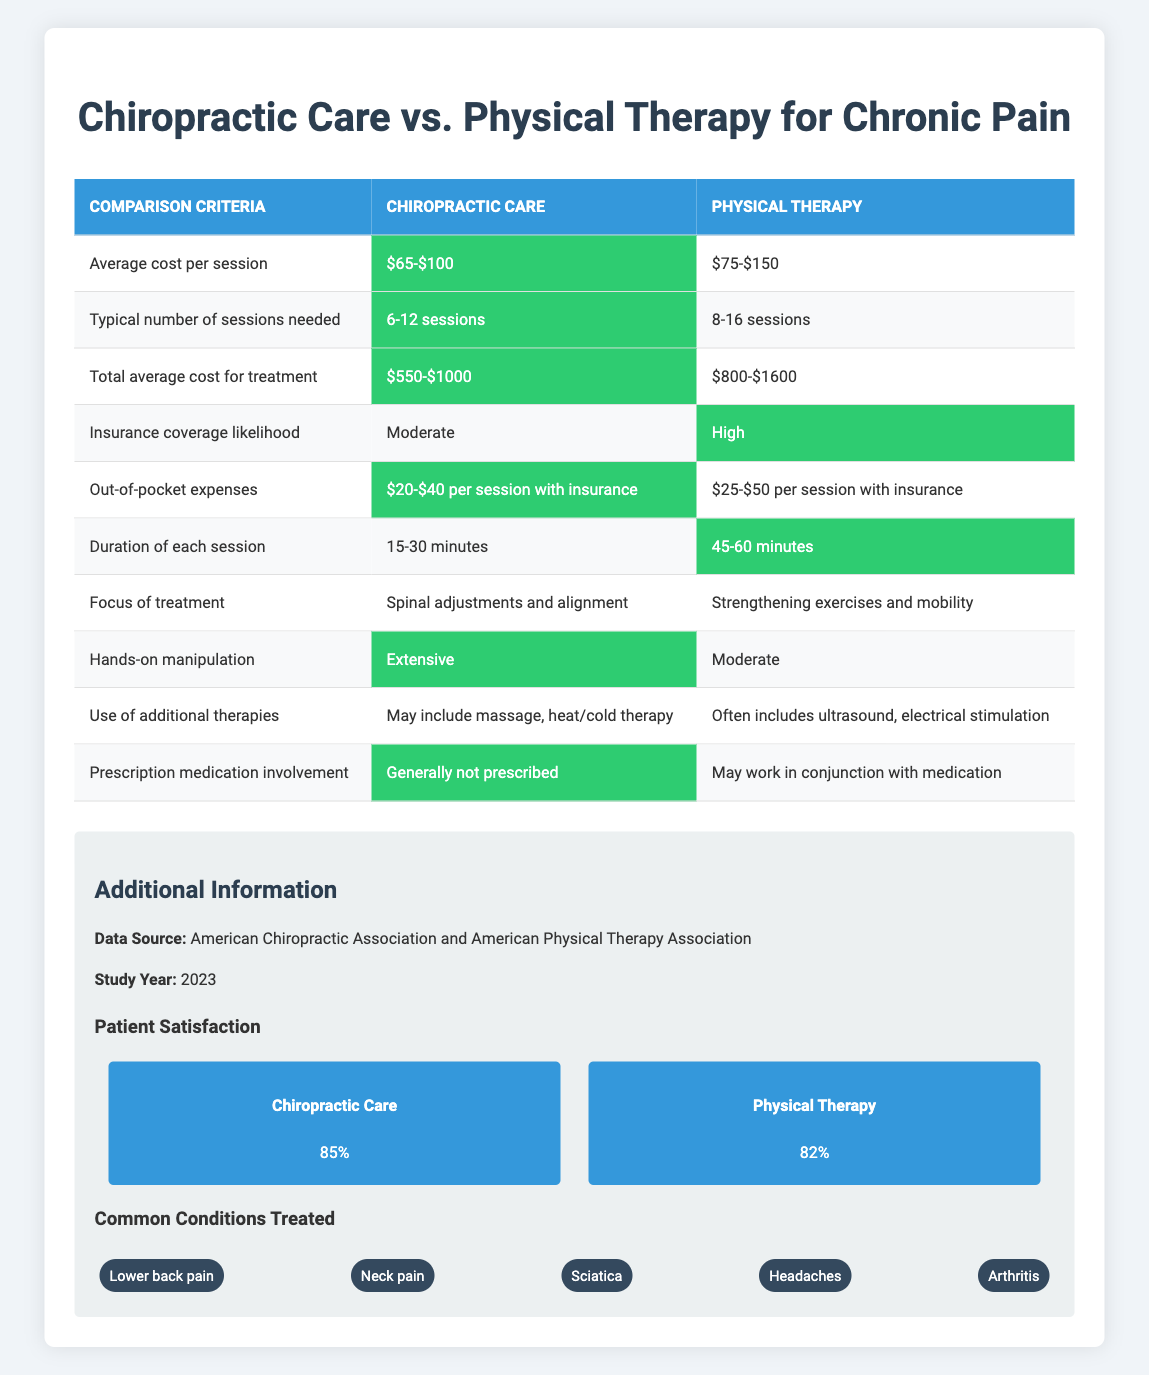What is the average cost per session for chiropractic care? The table states that the average cost per session for chiropractic care ranges from $65 to $100. This value is directly pulled from the table without needing additional calculations.
Answer: $65-$100 How many typical sessions are needed for physical therapy? According to the table, the typical number of sessions needed for physical therapy is between 8 to 16 sessions, as indicated in the relevant row for physical therapy.
Answer: 8-16 sessions What is the out-of-pocket expense per session for chiropractic care with insurance? The table provides a specific range for the out-of-pocket expense per session for chiropractic care with insurance, which is $20-$40. This is a direct retrieval of data from the table.
Answer: $20-$40 per session with insurance Which treatment has a higher total average cost for treatment? The total average cost for treatment shows chiropractic care costs between $550 to $1000 while physical therapy costs between $800 to $1600. Comparing these ranges, we see that physical therapy has a higher total average cost.
Answer: Physical therapy Is hands-on manipulation more extensive in chiropractic care compared to physical therapy? The table lists hands-on manipulation as extensive for chiropractic care and moderate for physical therapy. Therefore, it is true that chiropractic care has more extensive hands-on manipulation.
Answer: Yes What is the difference in duration of each session between chiropractic care and physical therapy? The duration of chiropractic care sessions ranges from 15 to 30 minutes, and for physical therapy, it is 45 to 60 minutes. To find the difference, we can take the maximum of physical therapy (60) and subtract the minimum of chiropractic care (15), resulting in a difference of 45 minutes. Alternatively, we can also calculate the average duration if needed, but the question specifically asks for the difference, which we've obtained.
Answer: 45 minutes What is the likelihood of insurance coverage for each treatment? The table indicates moderate likelihood for chiropractic care and high likelihood for physical therapy. The comparison shows that physical therapy is generally more likely to be covered by insurance compared to chiropractic care.
Answer: Higher for physical therapy What is the average number of sessions needed between both treatments? For chiropractic care, the typical number of sessions needed is 6-12 and for physical therapy 8-16. To find the average, we can calculate the mid-point of these ranges, which is (6+12)/2 = 9 and (8+16)/2 = 12. The overall average for both is then (9 + 12) / 2 = 10.5, giving us a rough estimate of the average number of sessions needed overall.
Answer: Approximately 10.5 sessions Does chiropractic care involve prescription medication? The table indicates that chiropractic care generally does not involve prescription medication, whereas physical therapy may work in conjunction with medication. Based on this comparison, the statement about chiropractic care is true.
Answer: No 